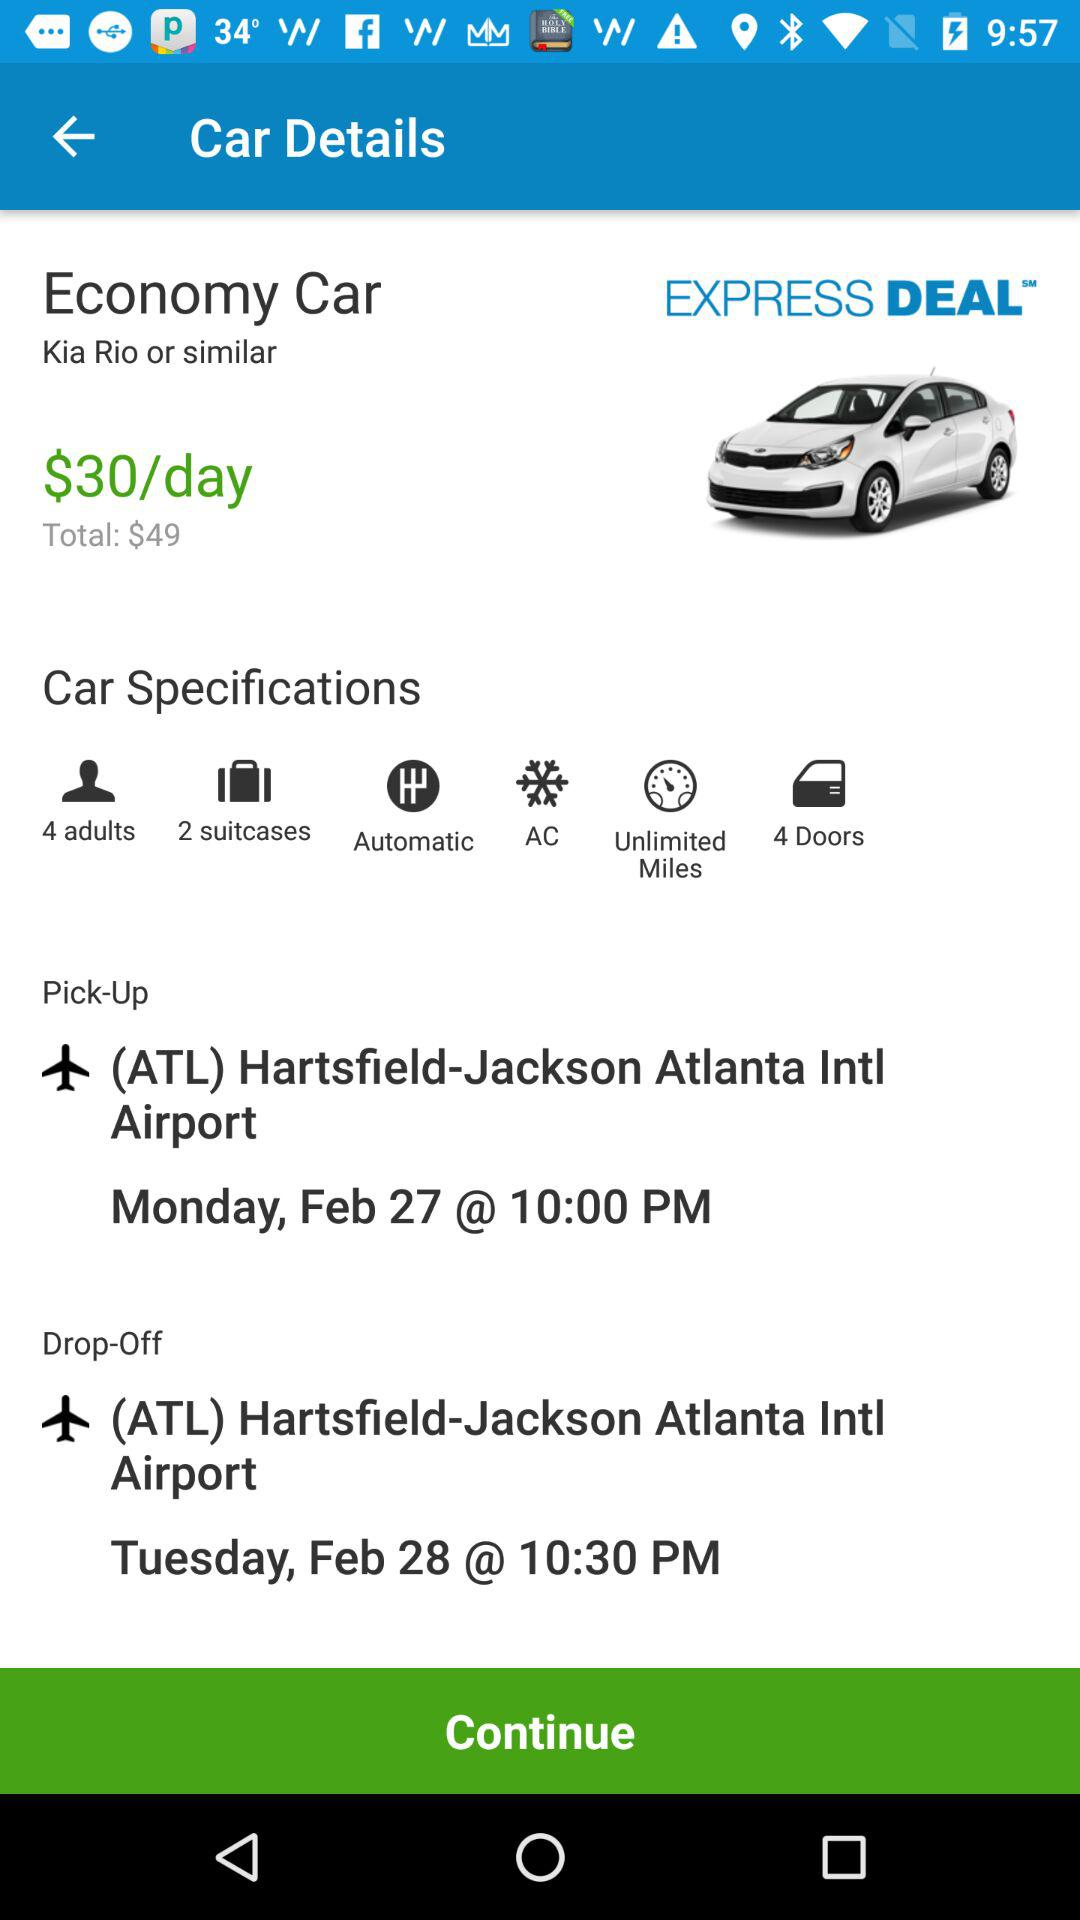How many more dollars is the total cost than the daily rate?
Answer the question using a single word or phrase. 19 